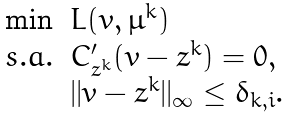<formula> <loc_0><loc_0><loc_500><loc_500>\begin{array} { l l } \min & L ( v , \mu ^ { k } ) \\ s . a . & C ^ { \prime } _ { z ^ { k } } ( v - z ^ { k } ) = 0 , \\ & | | v - z ^ { k } | | _ { \infty } \leq \delta _ { k , i } . \end{array}</formula> 